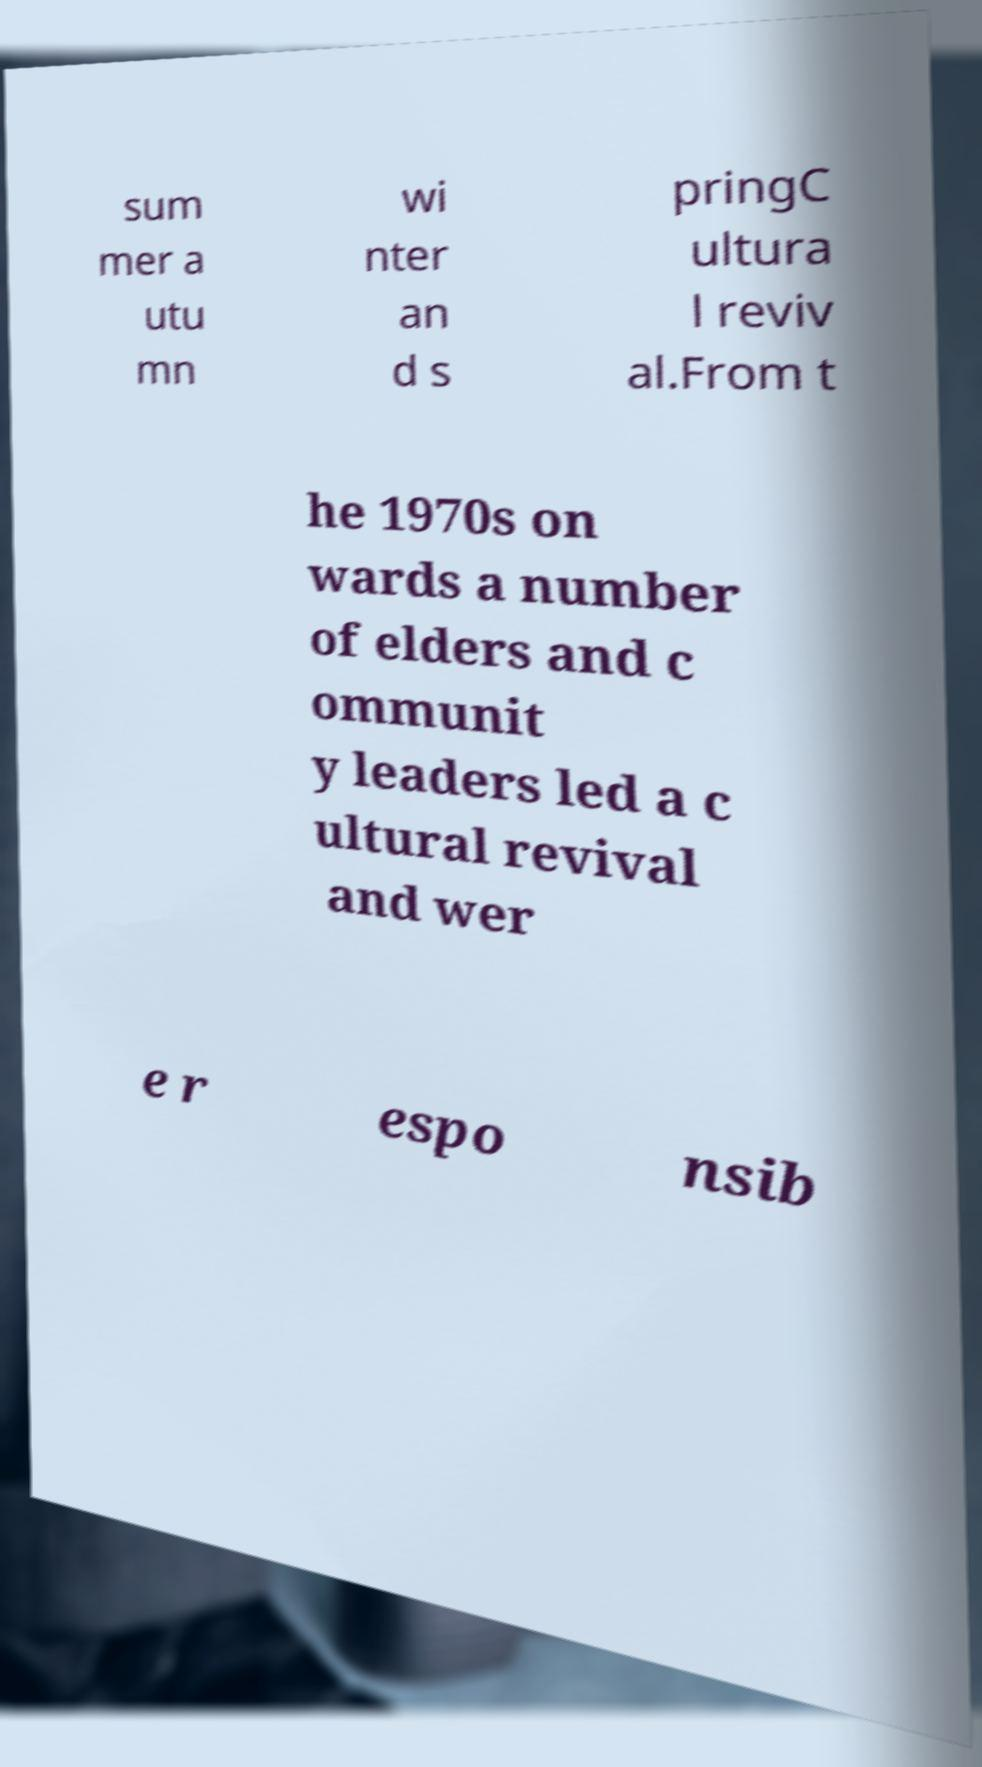For documentation purposes, I need the text within this image transcribed. Could you provide that? sum mer a utu mn wi nter an d s pringC ultura l reviv al.From t he 1970s on wards a number of elders and c ommunit y leaders led a c ultural revival and wer e r espo nsib 